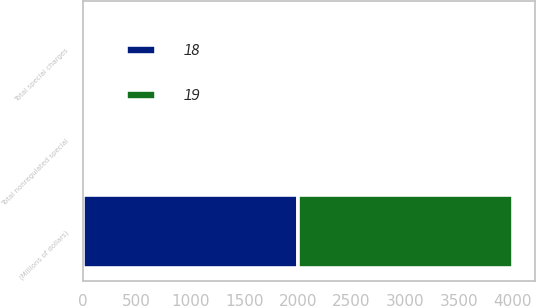Convert chart. <chart><loc_0><loc_0><loc_500><loc_500><stacked_bar_chart><ecel><fcel>(Millions of dollars)<fcel>Total nonregulated special<fcel>Total special charges<nl><fcel>19<fcel>2004<fcel>18<fcel>18<nl><fcel>18<fcel>2003<fcel>19<fcel>19<nl></chart> 